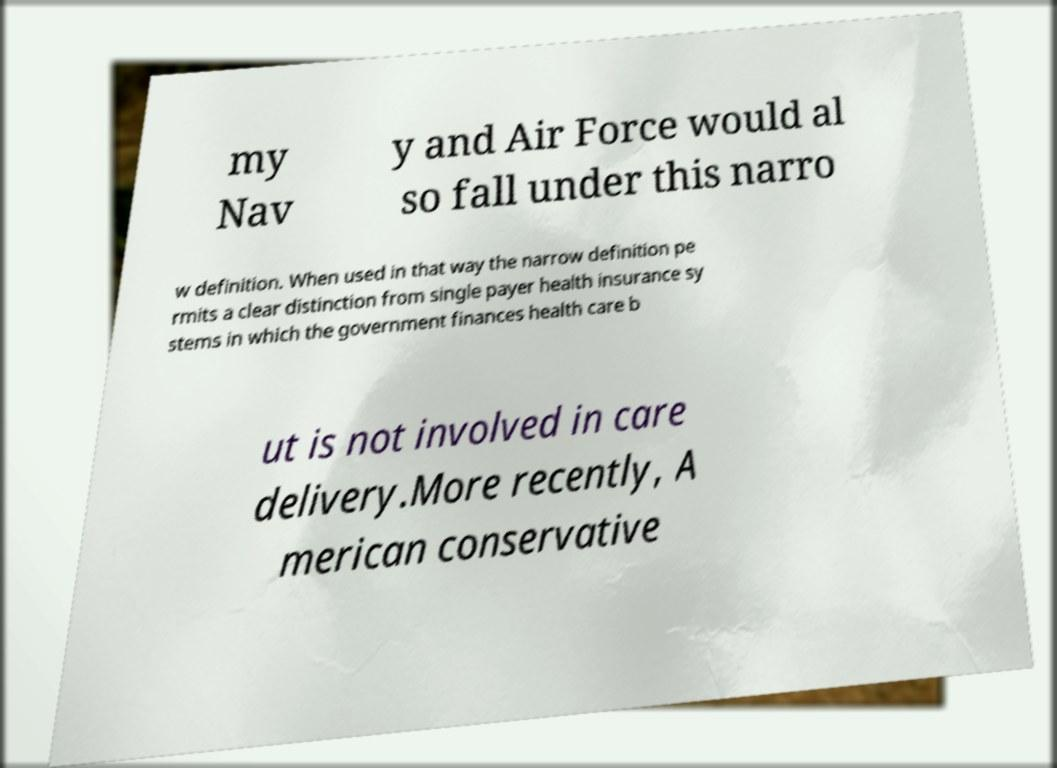There's text embedded in this image that I need extracted. Can you transcribe it verbatim? my Nav y and Air Force would al so fall under this narro w definition. When used in that way the narrow definition pe rmits a clear distinction from single payer health insurance sy stems in which the government finances health care b ut is not involved in care delivery.More recently, A merican conservative 